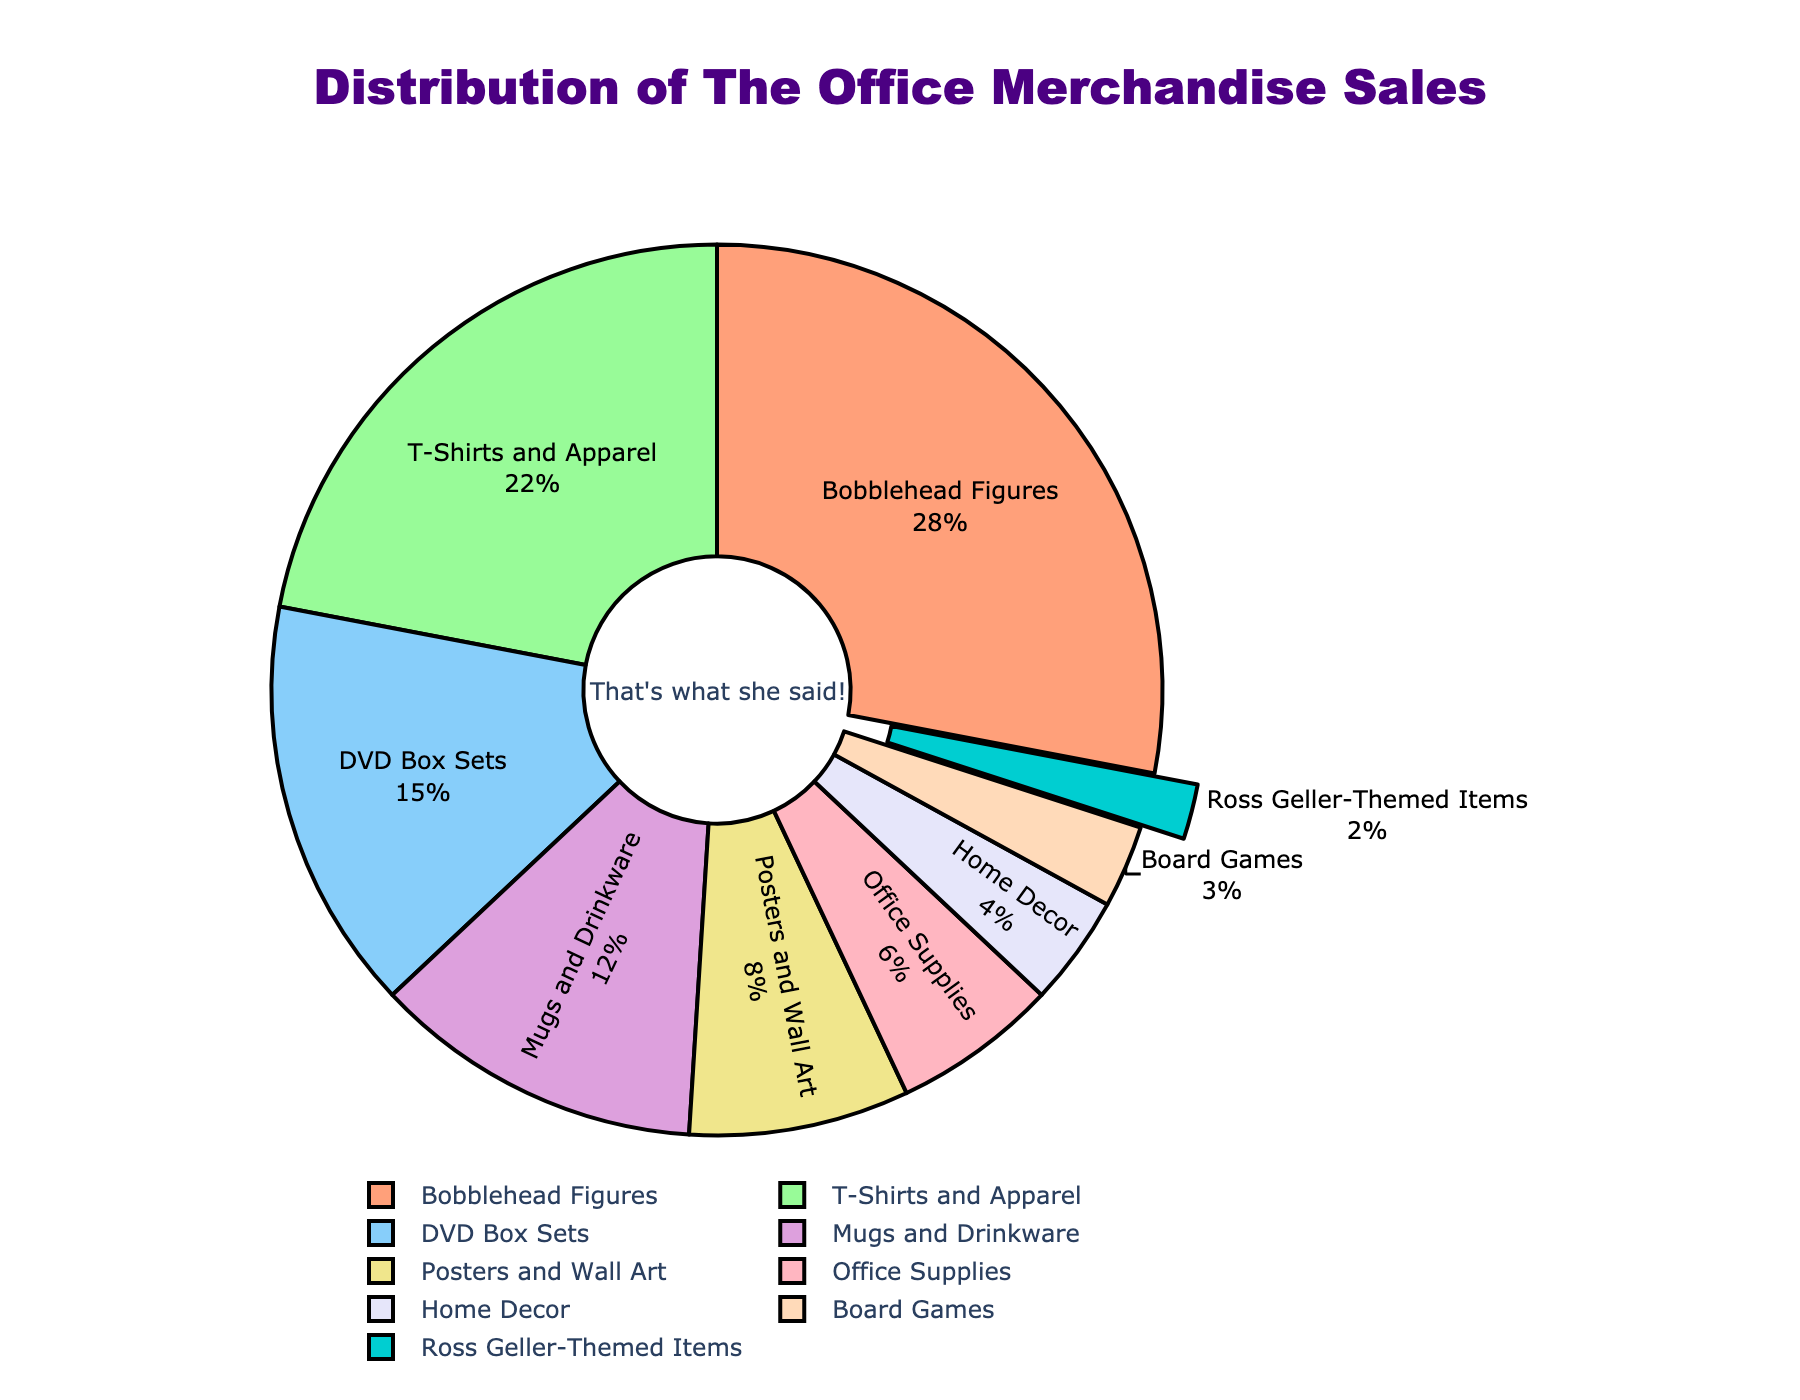What is the category with the highest percentage of merchandise sales? To find the category with the highest percentage, look for the section of the pie chart with the largest slice. It's labeled "Bobblehead Figures" with 28%.
Answer: Bobblehead Figures What is the combined percentage of sales for T-Shirts and Apparel and DVD Box Sets? Add the percentages for "T-Shirts and Apparel" (22%) and "DVD Box Sets" (15%). 22% + 15% = 37%.
Answer: 37% Which category has a smaller percentage of sales, Mugs and Drinkware or Office Supplies? Compare the percentages of "Mugs and Drinkware" (12%) and "Office Supplies" (6%). 6% is smaller than 12%.
Answer: Office Supplies By how much does the percentage of sales for Posters and Wall Art exceed that for Ross Geller-Themed Items? Subtract the percentage for "Ross Geller-Themed Items" (2%) from "Posters and Wall Art" (8%). 8% - 2% = 6%.
Answer: 6% What is the ratio of sales percentage between Board Games and Home Decor? Divide the percentage for "Board Games" (3%) by the percentage for "Home Decor" (4%). 3% / 4% = 0.75.
Answer: 0.75 Which product categories make up the smallest portion of sales and consist of less than 10% each? Identify categories with percentages less than 10%: "Posters and Wall Art" (8%), "Office Supplies" (6%), "Home Decor" (4%), "Board Games" (3%), and "Ross Geller-Themed Items" (2%).
Answer: Posters and Wall Art, Office Supplies, Home Decor, Board Games, Ross Geller-Themed Items What is the difference in sales percentage between the category with the highest sales and the one with the lowest sales? Subtract the percentage for the lowest category (Ross Geller-Themed Items, 2%) from the highest category (Bobblehead Figures, 28%). 28% - 2% = 26%.
Answer: 26% If the categories of T-Shirts and Apparel and DVD Box Sets were combined into one category called "Media and Apparel", what would be its new percentage? Add the percentages for "T-Shirts and Apparel" (22%) and "DVD Box Sets" (15%). 22% + 15% = 37%.
Answer: 37% What slice color represents the Mugs and Drinkware category in the pie chart? The slice representing "Mugs and Drinkware" is visually identifiable by its color, which is purple.
Answer: purple 